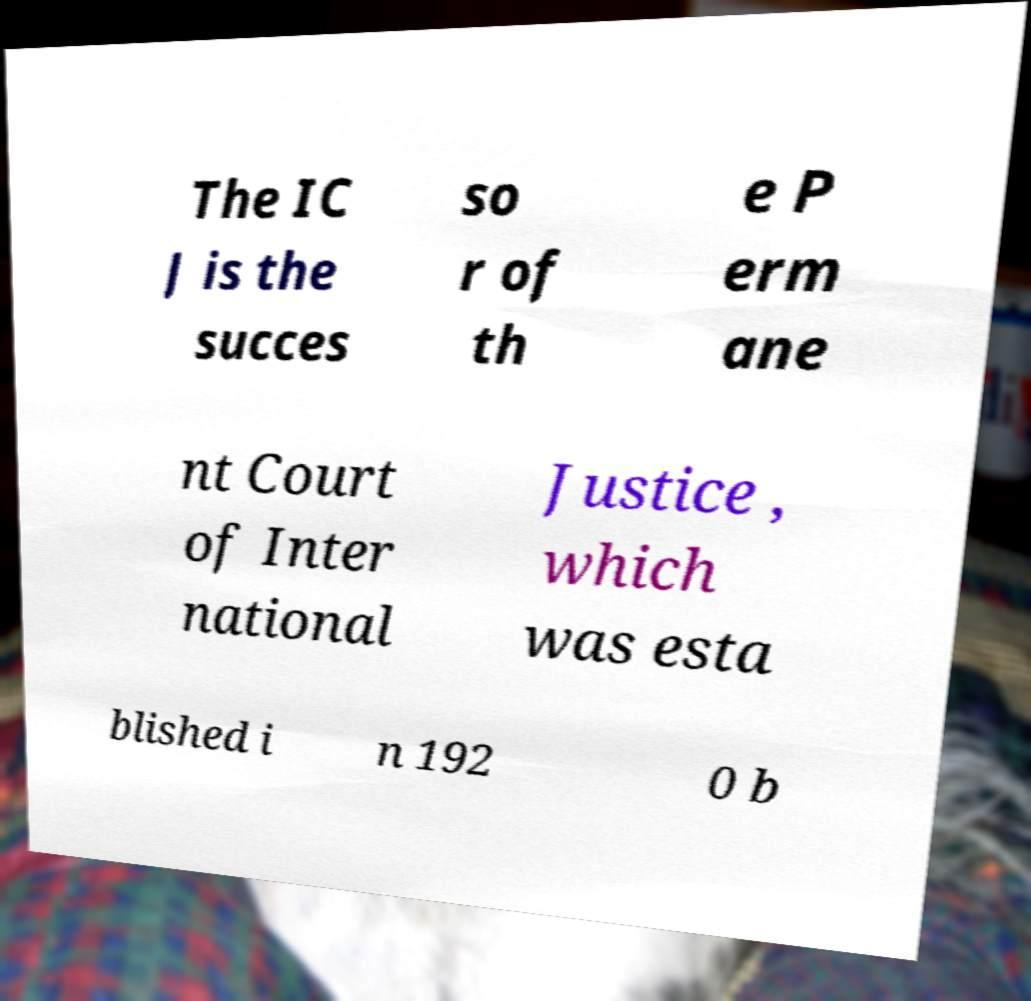What messages or text are displayed in this image? I need them in a readable, typed format. The IC J is the succes so r of th e P erm ane nt Court of Inter national Justice , which was esta blished i n 192 0 b 